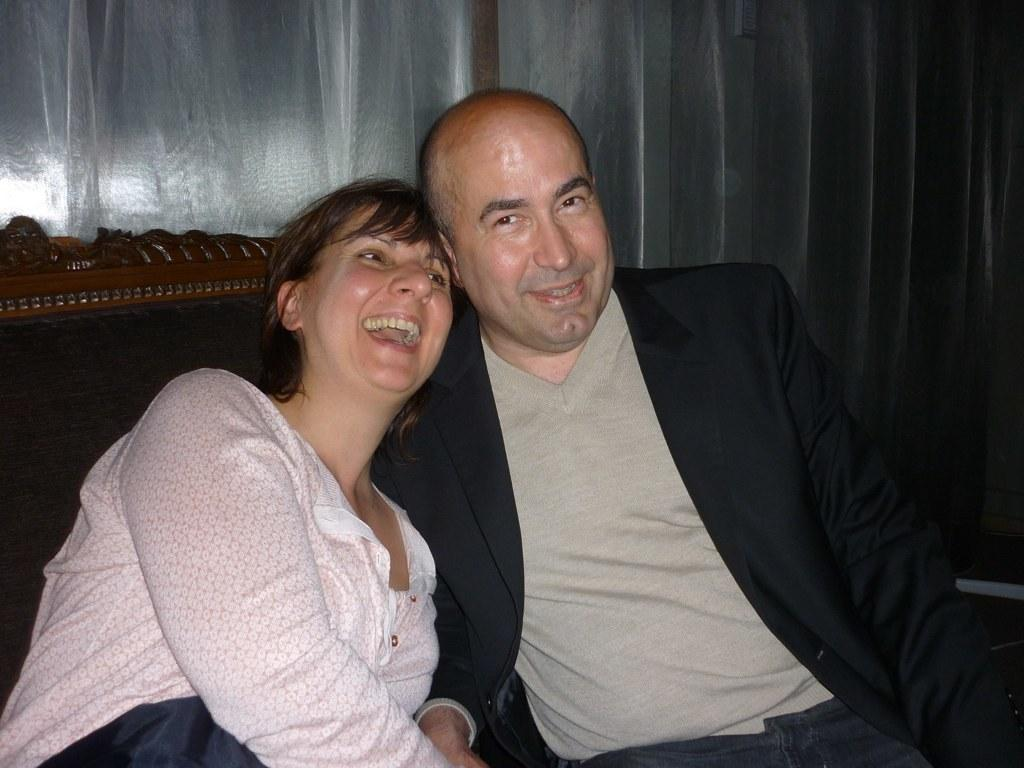How many people are present in the image? There are two people in the image, a man and a woman. What are the man and woman doing in the image? Both the man and woman are sitting in chairs. What expressions do the man and woman have in the image? The man is smiling, and the woman is laughing. What can be seen behind the chairs in the image? There is a white curtain behind the chair. What type of cracker is the man holding in the image? There is no cracker present in the image; the man is not holding anything. Can you tell me which country the map in the image is from? There is no map present in the image. 